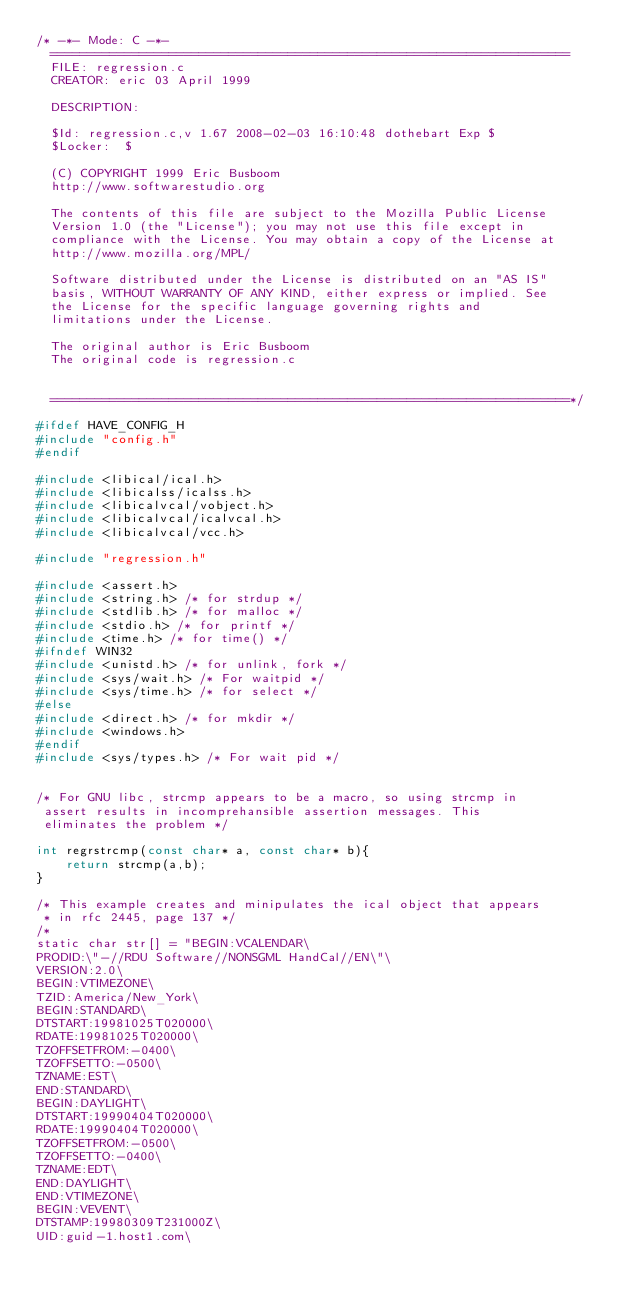<code> <loc_0><loc_0><loc_500><loc_500><_C_>/* -*- Mode: C -*-
  ======================================================================
  FILE: regression.c
  CREATOR: eric 03 April 1999

  DESCRIPTION:

  $Id: regression.c,v 1.67 2008-02-03 16:10:48 dothebart Exp $
  $Locker:  $

  (C) COPYRIGHT 1999 Eric Busboom
  http://www.softwarestudio.org

  The contents of this file are subject to the Mozilla Public License
  Version 1.0 (the "License"); you may not use this file except in
  compliance with the License. You may obtain a copy of the License at
  http://www.mozilla.org/MPL/

  Software distributed under the License is distributed on an "AS IS"
  basis, WITHOUT WARRANTY OF ANY KIND, either express or implied. See
  the License for the specific language governing rights and
  limitations under the License.

  The original author is Eric Busboom
  The original code is regression.c


  ======================================================================*/

#ifdef HAVE_CONFIG_H
#include "config.h"
#endif

#include <libical/ical.h>
#include <libicalss/icalss.h>
#include <libicalvcal/vobject.h>
#include <libicalvcal/icalvcal.h>
#include <libicalvcal/vcc.h>

#include "regression.h"

#include <assert.h>
#include <string.h> /* for strdup */
#include <stdlib.h> /* for malloc */
#include <stdio.h> /* for printf */
#include <time.h> /* for time() */
#ifndef WIN32
#include <unistd.h> /* for unlink, fork */
#include <sys/wait.h> /* For waitpid */
#include <sys/time.h> /* for select */
#else
#include <direct.h> /* for mkdir */
#include <windows.h>
#endif
#include <sys/types.h> /* For wait pid */


/* For GNU libc, strcmp appears to be a macro, so using strcmp in
 assert results in incomprehansible assertion messages. This
 eliminates the problem */

int regrstrcmp(const char* a, const char* b){
    return strcmp(a,b);
}

/* This example creates and minipulates the ical object that appears
 * in rfc 2445, page 137 */
/*
static char str[] = "BEGIN:VCALENDAR\
PRODID:\"-//RDU Software//NONSGML HandCal//EN\"\
VERSION:2.0\
BEGIN:VTIMEZONE\
TZID:America/New_York\
BEGIN:STANDARD\
DTSTART:19981025T020000\
RDATE:19981025T020000\
TZOFFSETFROM:-0400\
TZOFFSETTO:-0500\
TZNAME:EST\
END:STANDARD\
BEGIN:DAYLIGHT\
DTSTART:19990404T020000\
RDATE:19990404T020000\
TZOFFSETFROM:-0500\
TZOFFSETTO:-0400\
TZNAME:EDT\
END:DAYLIGHT\
END:VTIMEZONE\
BEGIN:VEVENT\
DTSTAMP:19980309T231000Z\
UID:guid-1.host1.com\</code> 